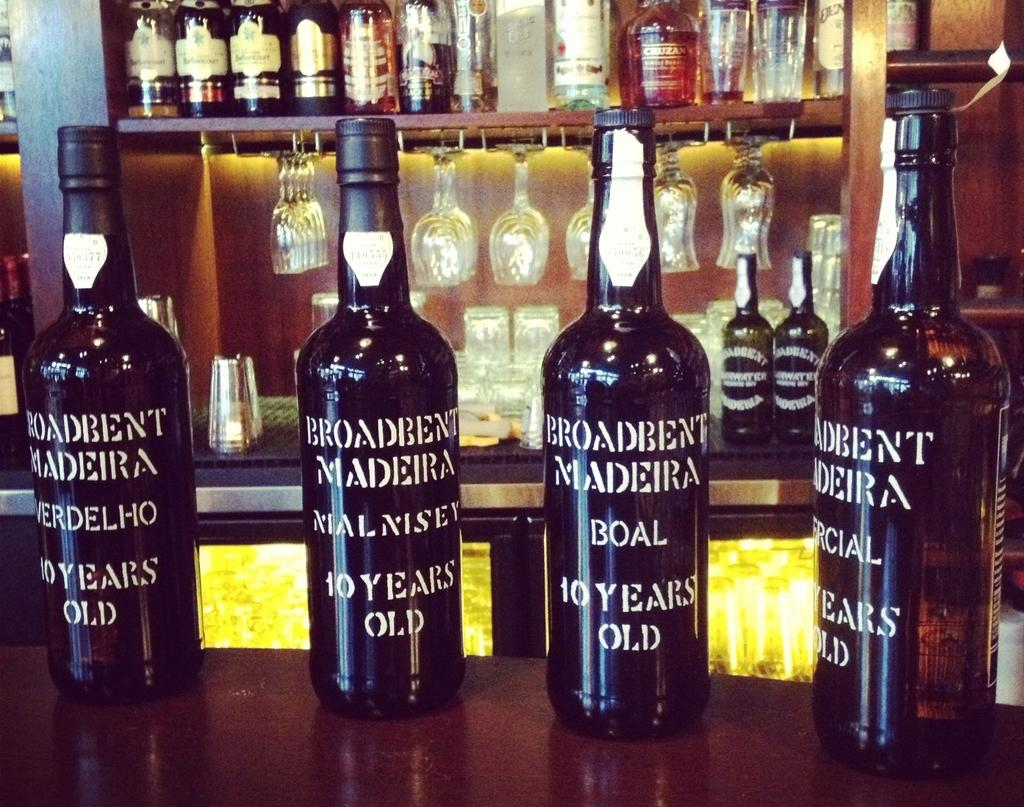What type of beverage is associated with the bottles on the table? There are wine bottles on the table. What type of glassware is present on the table? There are wine glasses behind the wine bottles on the table. Where are some of the wine bottles located? Some wine bottles are kept on a shelf. What type of powder is used to clean the wine bottles in the image? There is no powder present in the image, nor is there any indication of cleaning activities. 